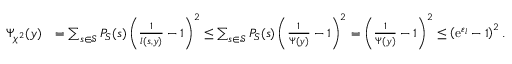Convert formula to latex. <formula><loc_0><loc_0><loc_500><loc_500>\begin{array} { r l } { \Psi _ { \chi ^ { 2 } } ( y ) } & { = \sum _ { s \in \mathcal { S } } P _ { S } ( s ) \left ( \frac { 1 } { l ( s , y ) } - 1 \right ) ^ { 2 } \leq \sum _ { s \in \mathcal { S } } P _ { S } ( s ) \left ( \frac { 1 } { \Psi ( y ) } - 1 \right ) ^ { 2 } = \left ( \frac { 1 } { \Psi ( y ) } - 1 \right ) ^ { 2 } \leq \left ( e ^ { \varepsilon _ { l } } - 1 \right ) ^ { 2 } . } \end{array}</formula> 